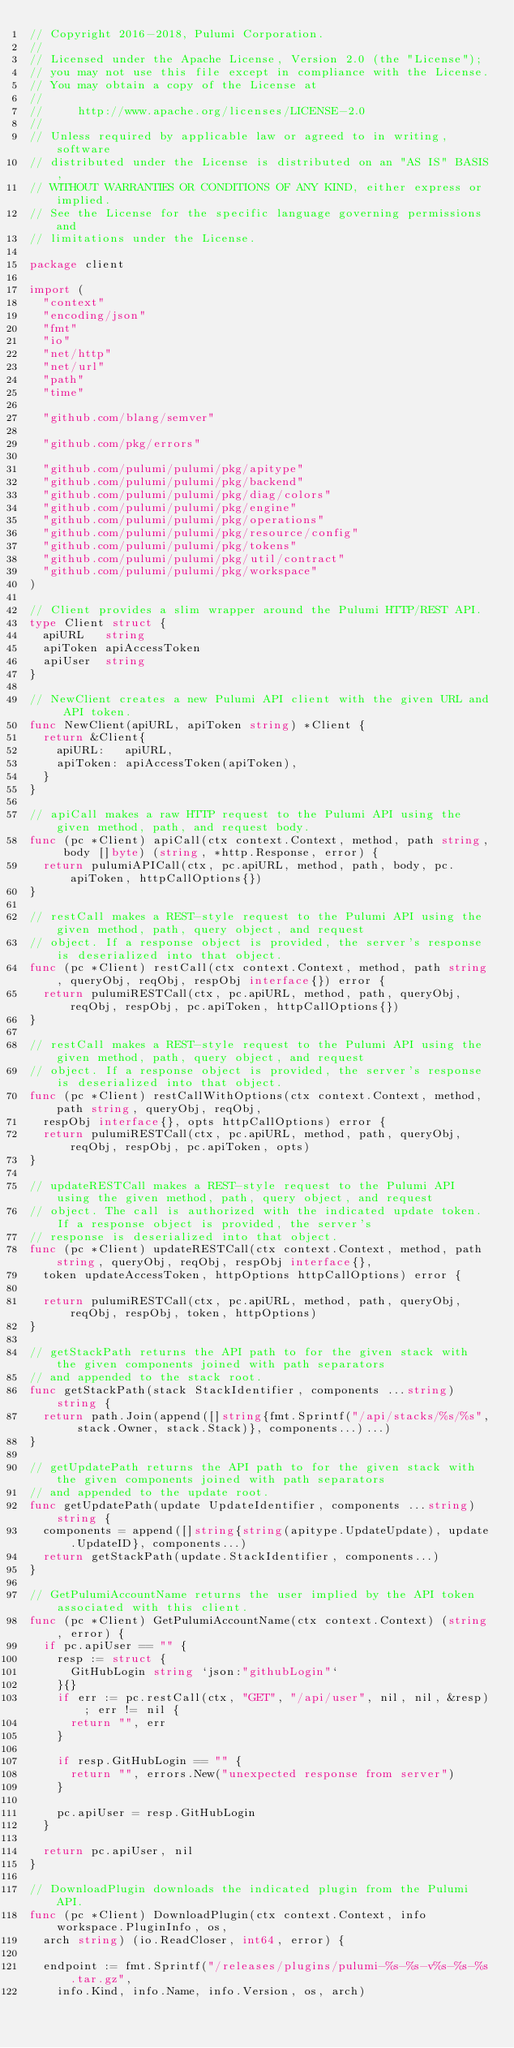<code> <loc_0><loc_0><loc_500><loc_500><_Go_>// Copyright 2016-2018, Pulumi Corporation.
//
// Licensed under the Apache License, Version 2.0 (the "License");
// you may not use this file except in compliance with the License.
// You may obtain a copy of the License at
//
//     http://www.apache.org/licenses/LICENSE-2.0
//
// Unless required by applicable law or agreed to in writing, software
// distributed under the License is distributed on an "AS IS" BASIS,
// WITHOUT WARRANTIES OR CONDITIONS OF ANY KIND, either express or implied.
// See the License for the specific language governing permissions and
// limitations under the License.

package client

import (
	"context"
	"encoding/json"
	"fmt"
	"io"
	"net/http"
	"net/url"
	"path"
	"time"

	"github.com/blang/semver"

	"github.com/pkg/errors"

	"github.com/pulumi/pulumi/pkg/apitype"
	"github.com/pulumi/pulumi/pkg/backend"
	"github.com/pulumi/pulumi/pkg/diag/colors"
	"github.com/pulumi/pulumi/pkg/engine"
	"github.com/pulumi/pulumi/pkg/operations"
	"github.com/pulumi/pulumi/pkg/resource/config"
	"github.com/pulumi/pulumi/pkg/tokens"
	"github.com/pulumi/pulumi/pkg/util/contract"
	"github.com/pulumi/pulumi/pkg/workspace"
)

// Client provides a slim wrapper around the Pulumi HTTP/REST API.
type Client struct {
	apiURL   string
	apiToken apiAccessToken
	apiUser  string
}

// NewClient creates a new Pulumi API client with the given URL and API token.
func NewClient(apiURL, apiToken string) *Client {
	return &Client{
		apiURL:   apiURL,
		apiToken: apiAccessToken(apiToken),
	}
}

// apiCall makes a raw HTTP request to the Pulumi API using the given method, path, and request body.
func (pc *Client) apiCall(ctx context.Context, method, path string, body []byte) (string, *http.Response, error) {
	return pulumiAPICall(ctx, pc.apiURL, method, path, body, pc.apiToken, httpCallOptions{})
}

// restCall makes a REST-style request to the Pulumi API using the given method, path, query object, and request
// object. If a response object is provided, the server's response is deserialized into that object.
func (pc *Client) restCall(ctx context.Context, method, path string, queryObj, reqObj, respObj interface{}) error {
	return pulumiRESTCall(ctx, pc.apiURL, method, path, queryObj, reqObj, respObj, pc.apiToken, httpCallOptions{})
}

// restCall makes a REST-style request to the Pulumi API using the given method, path, query object, and request
// object. If a response object is provided, the server's response is deserialized into that object.
func (pc *Client) restCallWithOptions(ctx context.Context, method, path string, queryObj, reqObj,
	respObj interface{}, opts httpCallOptions) error {
	return pulumiRESTCall(ctx, pc.apiURL, method, path, queryObj, reqObj, respObj, pc.apiToken, opts)
}

// updateRESTCall makes a REST-style request to the Pulumi API using the given method, path, query object, and request
// object. The call is authorized with the indicated update token. If a response object is provided, the server's
// response is deserialized into that object.
func (pc *Client) updateRESTCall(ctx context.Context, method, path string, queryObj, reqObj, respObj interface{},
	token updateAccessToken, httpOptions httpCallOptions) error {

	return pulumiRESTCall(ctx, pc.apiURL, method, path, queryObj, reqObj, respObj, token, httpOptions)
}

// getStackPath returns the API path to for the given stack with the given components joined with path separators
// and appended to the stack root.
func getStackPath(stack StackIdentifier, components ...string) string {
	return path.Join(append([]string{fmt.Sprintf("/api/stacks/%s/%s", stack.Owner, stack.Stack)}, components...)...)
}

// getUpdatePath returns the API path to for the given stack with the given components joined with path separators
// and appended to the update root.
func getUpdatePath(update UpdateIdentifier, components ...string) string {
	components = append([]string{string(apitype.UpdateUpdate), update.UpdateID}, components...)
	return getStackPath(update.StackIdentifier, components...)
}

// GetPulumiAccountName returns the user implied by the API token associated with this client.
func (pc *Client) GetPulumiAccountName(ctx context.Context) (string, error) {
	if pc.apiUser == "" {
		resp := struct {
			GitHubLogin string `json:"githubLogin"`
		}{}
		if err := pc.restCall(ctx, "GET", "/api/user", nil, nil, &resp); err != nil {
			return "", err
		}

		if resp.GitHubLogin == "" {
			return "", errors.New("unexpected response from server")
		}

		pc.apiUser = resp.GitHubLogin
	}

	return pc.apiUser, nil
}

// DownloadPlugin downloads the indicated plugin from the Pulumi API.
func (pc *Client) DownloadPlugin(ctx context.Context, info workspace.PluginInfo, os,
	arch string) (io.ReadCloser, int64, error) {

	endpoint := fmt.Sprintf("/releases/plugins/pulumi-%s-%s-v%s-%s-%s.tar.gz",
		info.Kind, info.Name, info.Version, os, arch)</code> 